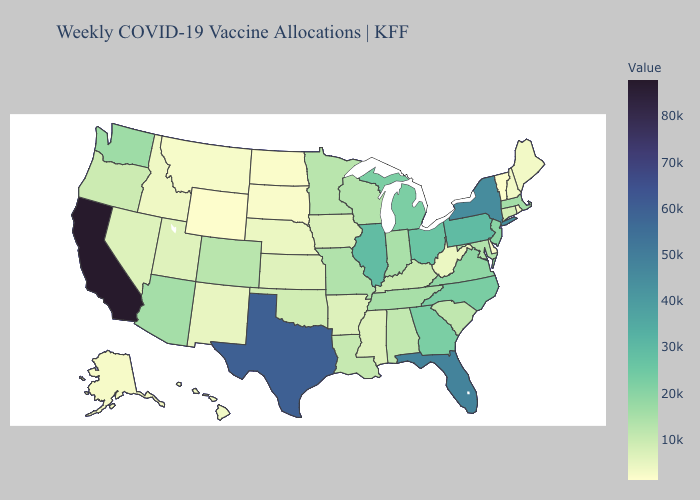Does Pennsylvania have the lowest value in the Northeast?
Concise answer only. No. Does Vermont have the lowest value in the Northeast?
Answer briefly. Yes. Does Vermont have the lowest value in the Northeast?
Concise answer only. Yes. Which states have the lowest value in the South?
Concise answer only. Delaware. Which states have the lowest value in the South?
Quick response, please. Delaware. Does Kansas have a higher value than Washington?
Concise answer only. No. Does Missouri have the lowest value in the USA?
Write a very short answer. No. 